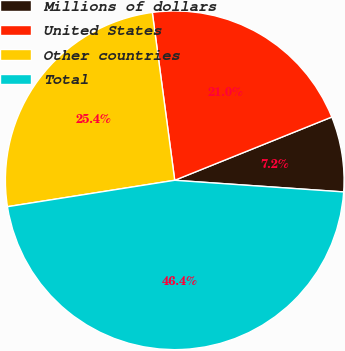Convert chart. <chart><loc_0><loc_0><loc_500><loc_500><pie_chart><fcel>Millions of dollars<fcel>United States<fcel>Other countries<fcel>Total<nl><fcel>7.19%<fcel>21.02%<fcel>25.38%<fcel>46.41%<nl></chart> 